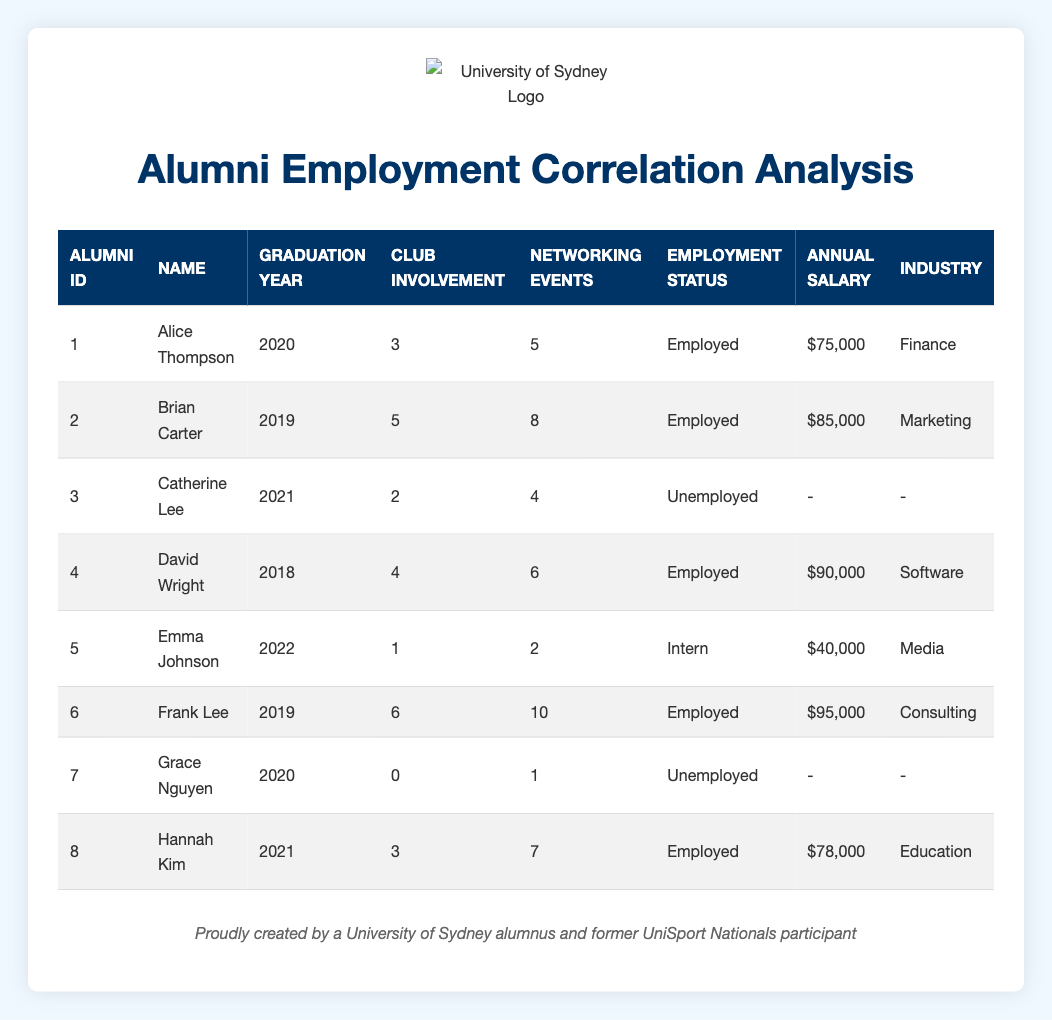What is the total club involvement of all alumni listed? To find the total club involvement, we need to sum the values in the "Club Involvement" column. This gives us 3 + 5 + 2 + 4 + 1 + 6 + 0 + 3 = 24
Answer: 24 How many alumni are currently employed? In the "Employment Status" column, we count the entries marked as "Employed." The entries for Alice Thompson, Brian Carter, David Wright, Frank Lee, and Hannah Kim are all employed, totaling 5 alumni.
Answer: 5 What is the average annual salary of the employed alumni? We first gather the annual salaries of employed alumni: 75000 for Alice, 85000 for Brian, 90000 for David, 95000 for Frank, and 78000 for Hannah. The total salary is 75000 + 85000 + 90000 + 95000 + 78000 = 423000. There are 5 employed alumni, so we divide 423000 by 5 to find the average: 423000 / 5 = 84600.
Answer: 84600 Is there any alumni who has attended no networking events and is unemployed? We look for entries where "Networking Events" is 0 and "Employment Status" is "Unemployed." Grace Nguyen fits both criteria, confirming that such an alumni exists.
Answer: Yes What is the median club involvement of the alumni? To determine the median, we sort the club involvement values: 0, 1, 2, 3, 3, 4, 5, 6. The median is the average of the 4th and 5th numbers in this sorted list. The 4th is 3 and the 5th is 4, so the median is (3 + 4) / 2 = 3.5.
Answer: 3.5 How many networking events did the alumni with the highest annual salary attend? The highest annual salary is 95000, corresponding to Frank Lee. We check his entry in the "Networking Events" column, where we find he attended 10 networking events.
Answer: 10 Are there any alumni with both club involvement of 4 or more and an industry listed? Reviewing the table, David Wright has a club involvement of 4 and is in the "Software" industry, and Frank Lee has a club involvement of 6 and is in "Consulting." Thus, there are alumni who meet these criteria.
Answer: Yes What is the difference in annual salary between the highest and lowest salaries among employed alumni? The highest salary among employed alumni is 95000 (from Frank Lee) and the lowest is 75000 (from Alice Thompson). We calculate the difference: 95000 - 75000 = 20000.
Answer: 20000 